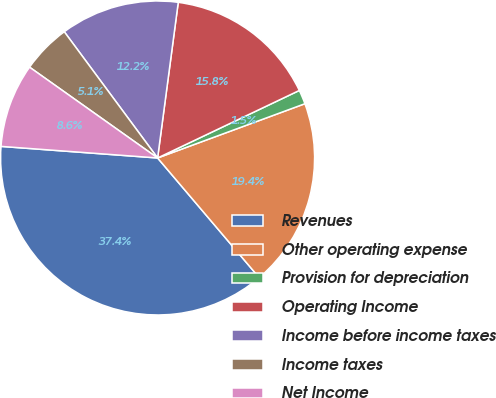Convert chart. <chart><loc_0><loc_0><loc_500><loc_500><pie_chart><fcel>Revenues<fcel>Other operating expense<fcel>Provision for depreciation<fcel>Operating Income<fcel>Income before income taxes<fcel>Income taxes<fcel>Net Income<nl><fcel>37.37%<fcel>19.41%<fcel>1.46%<fcel>15.82%<fcel>12.23%<fcel>5.05%<fcel>8.64%<nl></chart> 